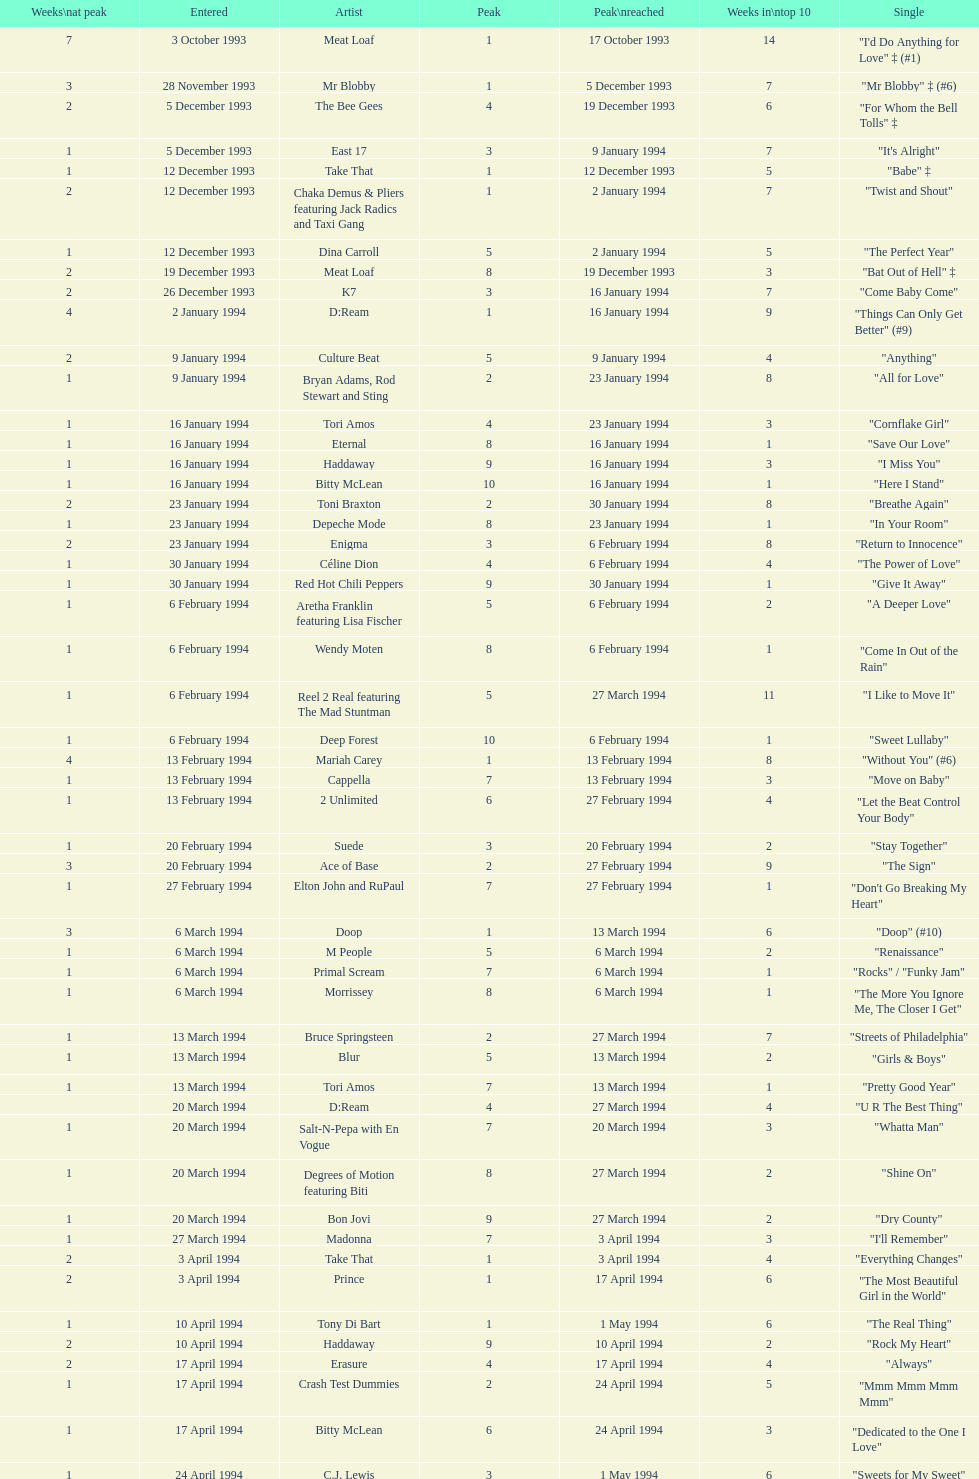Which artist came on the list after oasis? Tinman. Can you parse all the data within this table? {'header': ['Weeks\\nat peak', 'Entered', 'Artist', 'Peak', 'Peak\\nreached', 'Weeks in\\ntop 10', 'Single'], 'rows': [['7', '3 October 1993', 'Meat Loaf', '1', '17 October 1993', '14', '"I\'d Do Anything for Love" ‡ (#1)'], ['3', '28 November 1993', 'Mr Blobby', '1', '5 December 1993', '7', '"Mr Blobby" ‡ (#6)'], ['2', '5 December 1993', 'The Bee Gees', '4', '19 December 1993', '6', '"For Whom the Bell Tolls" ‡'], ['1', '5 December 1993', 'East 17', '3', '9 January 1994', '7', '"It\'s Alright"'], ['1', '12 December 1993', 'Take That', '1', '12 December 1993', '5', '"Babe" ‡'], ['2', '12 December 1993', 'Chaka Demus & Pliers featuring Jack Radics and Taxi Gang', '1', '2 January 1994', '7', '"Twist and Shout"'], ['1', '12 December 1993', 'Dina Carroll', '5', '2 January 1994', '5', '"The Perfect Year"'], ['2', '19 December 1993', 'Meat Loaf', '8', '19 December 1993', '3', '"Bat Out of Hell" ‡'], ['2', '26 December 1993', 'K7', '3', '16 January 1994', '7', '"Come Baby Come"'], ['4', '2 January 1994', 'D:Ream', '1', '16 January 1994', '9', '"Things Can Only Get Better" (#9)'], ['2', '9 January 1994', 'Culture Beat', '5', '9 January 1994', '4', '"Anything"'], ['1', '9 January 1994', 'Bryan Adams, Rod Stewart and Sting', '2', '23 January 1994', '8', '"All for Love"'], ['1', '16 January 1994', 'Tori Amos', '4', '23 January 1994', '3', '"Cornflake Girl"'], ['1', '16 January 1994', 'Eternal', '8', '16 January 1994', '1', '"Save Our Love"'], ['1', '16 January 1994', 'Haddaway', '9', '16 January 1994', '3', '"I Miss You"'], ['1', '16 January 1994', 'Bitty McLean', '10', '16 January 1994', '1', '"Here I Stand"'], ['2', '23 January 1994', 'Toni Braxton', '2', '30 January 1994', '8', '"Breathe Again"'], ['1', '23 January 1994', 'Depeche Mode', '8', '23 January 1994', '1', '"In Your Room"'], ['2', '23 January 1994', 'Enigma', '3', '6 February 1994', '8', '"Return to Innocence"'], ['1', '30 January 1994', 'Céline Dion', '4', '6 February 1994', '4', '"The Power of Love"'], ['1', '30 January 1994', 'Red Hot Chili Peppers', '9', '30 January 1994', '1', '"Give It Away"'], ['1', '6 February 1994', 'Aretha Franklin featuring Lisa Fischer', '5', '6 February 1994', '2', '"A Deeper Love"'], ['1', '6 February 1994', 'Wendy Moten', '8', '6 February 1994', '1', '"Come In Out of the Rain"'], ['1', '6 February 1994', 'Reel 2 Real featuring The Mad Stuntman', '5', '27 March 1994', '11', '"I Like to Move It"'], ['1', '6 February 1994', 'Deep Forest', '10', '6 February 1994', '1', '"Sweet Lullaby"'], ['4', '13 February 1994', 'Mariah Carey', '1', '13 February 1994', '8', '"Without You" (#6)'], ['1', '13 February 1994', 'Cappella', '7', '13 February 1994', '3', '"Move on Baby"'], ['1', '13 February 1994', '2 Unlimited', '6', '27 February 1994', '4', '"Let the Beat Control Your Body"'], ['1', '20 February 1994', 'Suede', '3', '20 February 1994', '2', '"Stay Together"'], ['3', '20 February 1994', 'Ace of Base', '2', '27 February 1994', '9', '"The Sign"'], ['1', '27 February 1994', 'Elton John and RuPaul', '7', '27 February 1994', '1', '"Don\'t Go Breaking My Heart"'], ['3', '6 March 1994', 'Doop', '1', '13 March 1994', '6', '"Doop" (#10)'], ['1', '6 March 1994', 'M People', '5', '6 March 1994', '2', '"Renaissance"'], ['1', '6 March 1994', 'Primal Scream', '7', '6 March 1994', '1', '"Rocks" / "Funky Jam"'], ['1', '6 March 1994', 'Morrissey', '8', '6 March 1994', '1', '"The More You Ignore Me, The Closer I Get"'], ['1', '13 March 1994', 'Bruce Springsteen', '2', '27 March 1994', '7', '"Streets of Philadelphia"'], ['1', '13 March 1994', 'Blur', '5', '13 March 1994', '2', '"Girls & Boys"'], ['1', '13 March 1994', 'Tori Amos', '7', '13 March 1994', '1', '"Pretty Good Year"'], ['', '20 March 1994', 'D:Ream', '4', '27 March 1994', '4', '"U R The Best Thing"'], ['1', '20 March 1994', 'Salt-N-Pepa with En Vogue', '7', '20 March 1994', '3', '"Whatta Man"'], ['1', '20 March 1994', 'Degrees of Motion featuring Biti', '8', '27 March 1994', '2', '"Shine On"'], ['1', '20 March 1994', 'Bon Jovi', '9', '27 March 1994', '2', '"Dry County"'], ['1', '27 March 1994', 'Madonna', '7', '3 April 1994', '3', '"I\'ll Remember"'], ['2', '3 April 1994', 'Take That', '1', '3 April 1994', '4', '"Everything Changes"'], ['2', '3 April 1994', 'Prince', '1', '17 April 1994', '6', '"The Most Beautiful Girl in the World"'], ['1', '10 April 1994', 'Tony Di Bart', '1', '1 May 1994', '6', '"The Real Thing"'], ['2', '10 April 1994', 'Haddaway', '9', '10 April 1994', '2', '"Rock My Heart"'], ['2', '17 April 1994', 'Erasure', '4', '17 April 1994', '4', '"Always"'], ['1', '17 April 1994', 'Crash Test Dummies', '2', '24 April 1994', '5', '"Mmm Mmm Mmm Mmm"'], ['1', '17 April 1994', 'Bitty McLean', '6', '24 April 1994', '3', '"Dedicated to the One I Love"'], ['1', '24 April 1994', 'C.J. Lewis', '3', '1 May 1994', '6', '"Sweets for My Sweet"'], ['1', '24 April 1994', 'The Pretenders', '10', '24 April 1994', '1', '"I\'ll Stand by You"'], ['1', '1 May 1994', 'Stiltskin', '1', '8 May 1994', '6', '"Inside"'], ['1', '1 May 1994', 'Clubhouse featuring Carl', '7', '1 May 1994', '2', '"Light My Fire"'], ['2', '1 May 1994', 'Manchester United Football Squad featuring Status Quo', '1', '15 May 1994', '7', '"Come on You Reds"'], ['2', '8 May 1994', 'East 17', '3', '15 May 1994', '5', '"Around the World"'], ['1', '8 May 1994', 'Eternal', '8', '15 May 1994', '3', '"Just a Step from Heaven"'], ['15', '15 May 1994', 'Wet Wet Wet', '1', '29 May 1994', '20', '"Love Is All Around" (#1)'], ['1', '15 May 1994', '2 Unlimited', '6', '22 May 1994', '3', '"The Real Thing"'], ['1', '15 May 1994', 'Bad Boys Inc', '8', '22 May 1994', '2', '"More to This World"'], ['2', '22 May 1994', 'Maxx', '4', '29 May 1994', '5', '"Get-A-Way"'], ['1', '22 May 1994', 'The Prodigy', '4', '12 June 1994', '6', '"No Good (Start the Dance)"'], ['3', '29 May 1994', 'Big Mountain', '2', '5 June 1994', '7', '"Baby, I Love Your Way"'], ['1', '29 May 1994', 'Gloworm', '9', '29 May 1994', '1', '"Carry Me Home"'], ['1', '5 June 1994', 'Absolutely Fabulous', '6', '12 June 1994', '3', '"Absolutely Fabulous"'], ['2', '5 June 1994', 'Dawn Penn', '3', '12 June 1994', '5', '"You Don\'t Love Me (No, No, No)"'], ['1', '5 June 1994', 'Guns N Roses', '10', '5 June 1994', '1', '"Since I Don\'t Have You"'], ['1', '12 June 1994', 'Ace of Base', '5', '19 June 1994', '3', '"Don\'t Turn Around"'], ['1', '12 June 1994', 'The Grid', '3', '26 June 1994', '8', '"Swamp Thing"'], ['1', '12 June 1994', 'Mariah Carey', '8', '19 June 1994', '2', '"Anytime You Need a Friend"'], ['7', '19 June 1994', 'All-4-One', '2', '26 June 1994', '12', '"I Swear" (#5)'], ['2', '26 June 1994', 'Reel 2 Real featuring The Mad Stuntman', '7', '26 June 1994', '2', '"Go On Move"'], ['1', '26 June 1994', 'Aswad', '5', '17 July 1994', '6', '"Shine"'], ['1', '26 June 1994', 'Cappella', '10', '26 June 1994', '1', '"U & Me"'], ['2', '3 July 1994', 'Take That', '3', '3 July 1994', '3', '"Love Ain\'t Here Anymore"'], ['3', '3 July 1994', 'The B.C. 52s', '3', '17 July 1994', '7', '"(Meet) The Flintstones"'], ['1', '3 July 1994', 'GUN', '8', '3 July 1994', '2', '"Word Up!"'], ['1', '10 July 1994', '2 Cowboys', '7', '10 July 1994', '2', '"Everybody Gonfi-Gon"'], ['2', '10 July 1994', 'Let Loose', '2', '14 August 1994', '9', '"Crazy for You" (#8)'], ['1', '17 July 1994', 'Warren G and Nate Dogg', '5', '24 July 1994', '8', '"Regulate"'], ['2', '17 July 1994', 'C.J. Lewis', '10', '17 July 1994', '2', '"Everything is Alright (Uptight)"'], ['1', '24 July 1994', 'Erasure', '6', '24 July 1994', '1', '"Run to the Sun"'], ['2', '24 July 1994', 'China Black', '4', '7 August 1994', '7', '"Searching"'], ['1', '31 July 1994', 'PJ & Duncan', '1', '31 March 2013', '4', '"Let\'s Get Ready to Rhumble"'], ['1', '31 July 1994', 'Maxx', '8', '7 August 1994', '2', '"No More (I Can\'t Stand It)"'], ['1', '7 August 1994', 'Red Dragon with Brian and Tony Gold', '2', '28 August 1994', '6', '"Compliments on Your Kiss"'], ['1', '7 August 1994', 'DJ Miko', '6', '14 August 1994', '4', '"What\'s Up?"'], ['1', '14 August 1994', "Youssou N'Dour featuring Neneh Cherry", '3', '4 September 1994', '6', '"7 Seconds"'], ['2', '14 August 1994', 'Oasis', '10', '14 August 1994', '2', '"Live Forever"'], ['1', '21 August 1994', 'Tinman', '9', '21 August 1994', '1', '"Eighteen Strings"'], ['1', '28 August 1994', 'Boyz II Men', '5', '4 September 1994', '5', '"I\'ll Make Love to You"'], ['1', '28 August 1994', 'Blur', '10', '28 August 1994', '1', '"Parklife"'], ['1', '4 September 1994', 'Kylie Minogue', '2', '4 September 1994', '3', '"Confide in Me"'], ['2', '4 September 1994', 'Corona', '2', '18 September 1994', '6', '"The Rhythm of the Night"'], ['4', '11 September 1994', 'Whigfield', '1', '11 September 1994', '10', '"Saturday Night" (#2)'], ['2', '11 September 1994', 'Luther Vandross and Mariah Carey', '3', '11 September 1994', '4', '"Endless Love"'], ['1', '11 September 1994', 'R.E.M.', '9', '11 September 1994', '2', '"What\'s the Frequency, Kenneth"'], ['1', '11 September 1994', 'M-Beat featuring General Levy', '8', '18 September 1994', '3', '"Incredible"'], ['3', '18 September 1994', 'Bon Jovi', '2', '2 October 1994', '11', '"Always" (#7)'], ['1', '25 September 1994', 'Cyndi Lauper', '4', '2 October 1994', '6', '"Hey Now (Girls Just Want to Have Fun)"'], ['1', '25 September 1994', 'Lisa Loeb and Nine Stories', '6', '25 September 1994', '6', '"Stay (I Missed You)"'], ['2', '25 September 1994', 'East 17', '7', '25 September 1994', '3', '"Steam"'], ['1', '2 October 1994', 'Madonna', '5', '2 October 1994', '2', '"Secret"'], ['4', '2 October 1994', 'Pato Banton featuring Ali and Robin Campbell', '1', '23 October 1994', '10', '"Baby Come Back" (#4)'], ['1', '2 October 1994', 'Michelle Gayle', '4', '30 October 1994', '6', '"Sweetness"'], ['2', '9 October 1994', 'Take That', '1', '9 October 1994', '3', '"Sure"'], ['1', '16 October 1994', 'Oasis', '7', '16 October 1994', '1', '"Cigarettes & Alcohol"'], ['1', '16 October 1994', 'Snap! featuring Summer', '6', '30 October 1994', '4', '"Welcome to Tomorrow (Are You Ready?)"'], ['1', '16 October 1994', 'R. Kelly', '3', '6 November 1994', '5', '"She\'s Got That Vibe"'], ['1', '23 October 1994', 'Sting', '9', '23 October 1994', '1', '"When We Dance"'], ['1', '30 October 1994', 'Eternal', '4', '6 November 1994', '4', '"Oh Baby I..."'], ['1', '30 October 1994', 'Ultimate Kaos', '9', '30 October 1994', '2', '"Some Girls"'], ['1', '6 November 1994', 'MC Sar and Real McCoy', '2', '13 November 1994', '5', '"Another Night"'], ['1', '6 November 1994', 'Sheryl Crow', '4', '20 November 1994', '4', '"All I Wanna Do"'], ['2', '13 November 1994', 'Baby D', '1', '20 November 1994', '5', '"Let Me Be Your Fantasy"'], ['1', '13 November 1994', 'M People', '6', '20 November 1994', '3', '"Sight for Sore Eyes"'], ['1', '13 November 1994', 'New Order', '9', '13 November 1994', '1', '"True Faith \'94"'], ['1', '20 November 1994', 'Louis Armstrong', '3', '27 November 1994', '6', '"We Have All the Time in the World"'], ['1', '20 November 1994', 'Jimmy Nail', '4', '4 December 1994', '7', '"Crocodile Shoes"'], ['1', '20 November 1994', 'Pearl Jam', '10', '20 November 1994', '1', '"Spin the Black Circle"'], ['1', '27 November 1994', 'The Stone Roses', '2', '27 November 1994', '2', '"Love Spreads"'], ['5', '27 November 1994', 'East 17', '1', '4 December 1994', '8', '"Stay Another Day" (#3)'], ['3', '4 December 1994', 'Mariah Carey', '2', '11 December 1994', '5', '"All I Want for Christmas Is You"'], ['1', '11 December 1994', 'The Mighty RAW', '3', '11 December', '3', '"Power Rangers: The Official Single"'], ['7', '4 December 1994', 'Celine Dion', '1', '29 January 1995', '17', '"Think Twice" ♦'], ['1', '4 December 1994', 'Boyzone', '2', '1 January 1995', '8', '"Love Me for a Reason" ♦'], ['1', '11 December 1994', 'Bon Jovi', '7', '11 December 1994', '2', '"Please Come Home for Christmas"'], ['1', '11 December 1994', 'Whigfield', '7', '1 January 1995', '2', '"Another Day" ♦'], ['3', '18 December 1994', 'Rednex', '1', '8 January 1995', '10', '"Cotton Eye Joe" ♦'], ['1', '18 December 1994', 'Zig and Zag', '5', '1 January 1995', '4', '"Them Girls, Them Girls" ♦'], ['1', '25 December 1994', 'Oasis', '3', '25 December 1994', '4', '"Whatever"']]} 